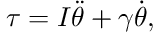<formula> <loc_0><loc_0><loc_500><loc_500>\tau = I \ddot { \theta } + \gamma \dot { \theta } ,</formula> 